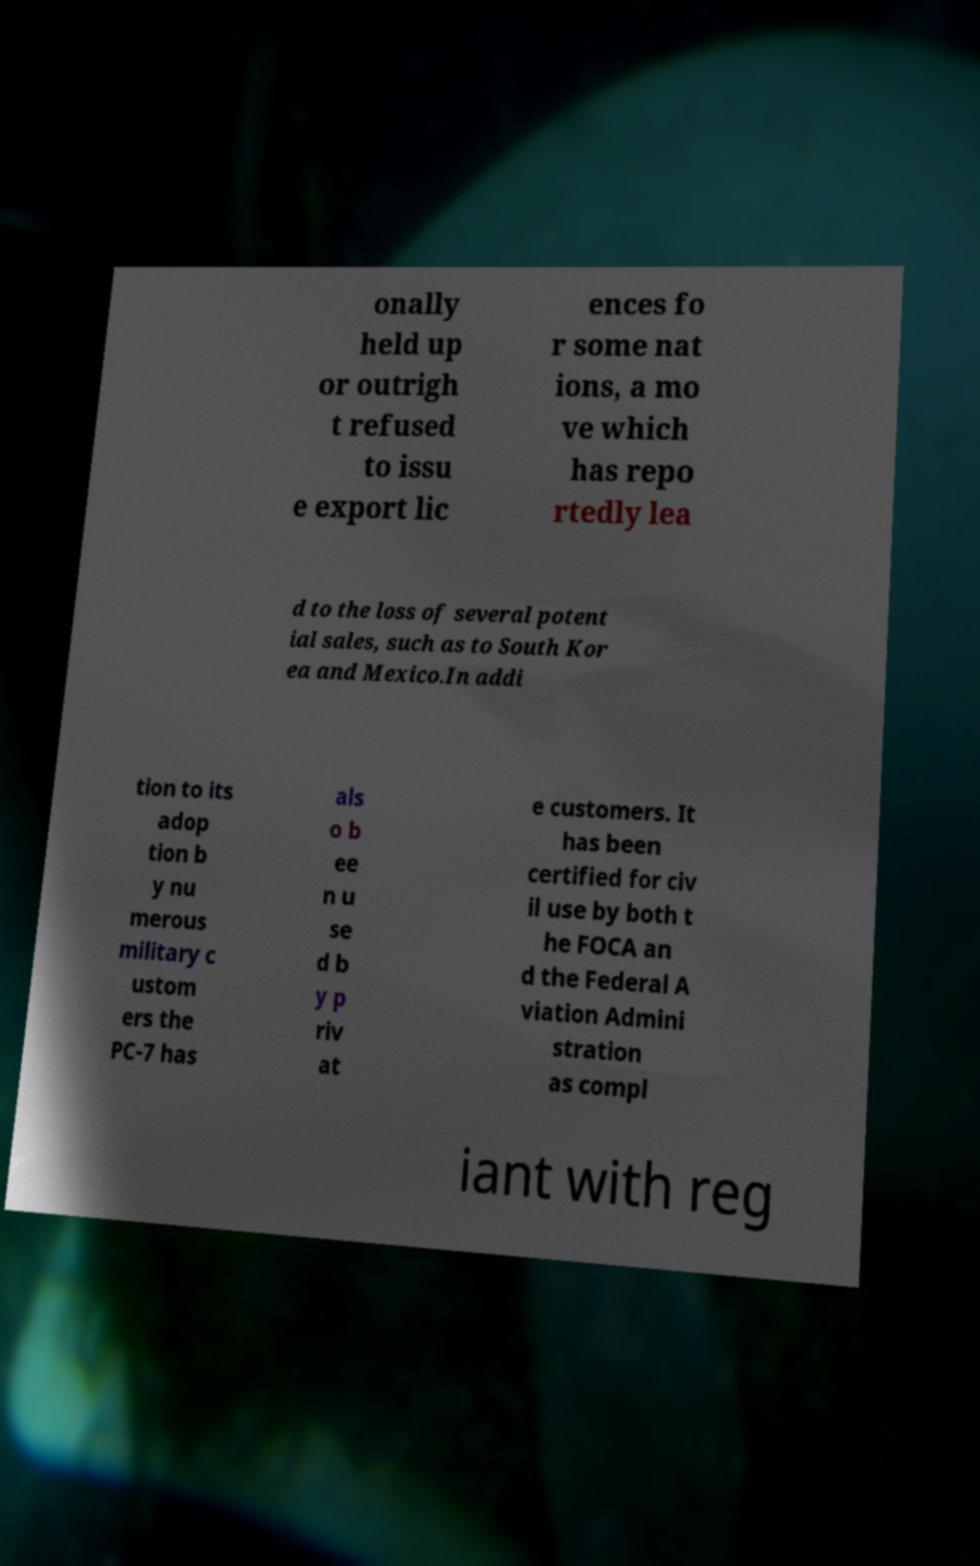Could you extract and type out the text from this image? onally held up or outrigh t refused to issu e export lic ences fo r some nat ions, a mo ve which has repo rtedly lea d to the loss of several potent ial sales, such as to South Kor ea and Mexico.In addi tion to its adop tion b y nu merous military c ustom ers the PC-7 has als o b ee n u se d b y p riv at e customers. It has been certified for civ il use by both t he FOCA an d the Federal A viation Admini stration as compl iant with reg 